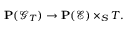Convert formula to latex. <formula><loc_0><loc_0><loc_500><loc_500>P ( { \mathcal { G } } _ { T } ) \to P ( { \mathcal { E } } ) \times _ { S } T .</formula> 